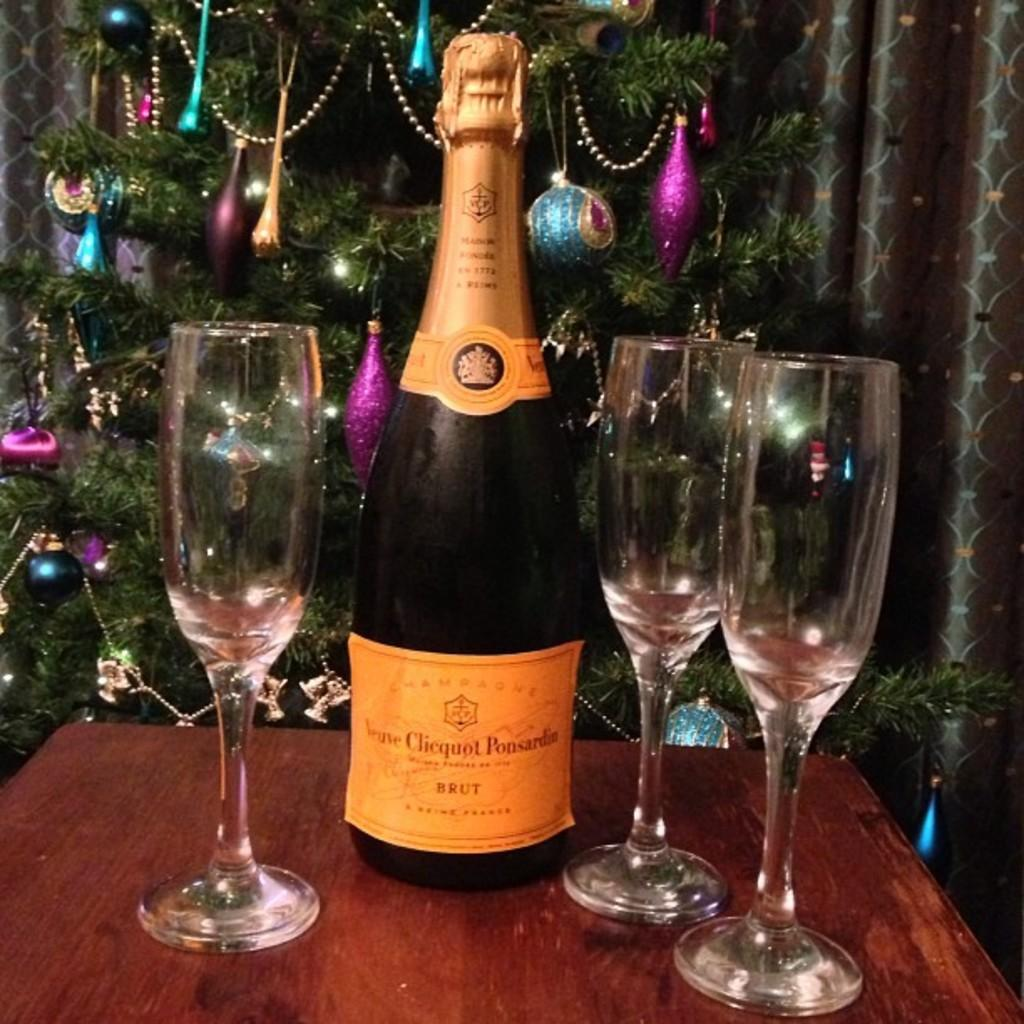What type of product is in the bottle shown in the image? There is a shampoo bottle in the image. What objects are on the table in the image? There are three glasses on a table in the image. What holiday-related decoration can be seen in the image? There is a Christmas tree in the image. What type of structure is visible in the image? There is a building in the image. How many mittens are on the table in the image? There are no mittens present in the image. What level of expertise is required to use the shampoo bottle in the image? The shampoo bottle does not require any specific level of expertise to use; it is it is designed for general use. 